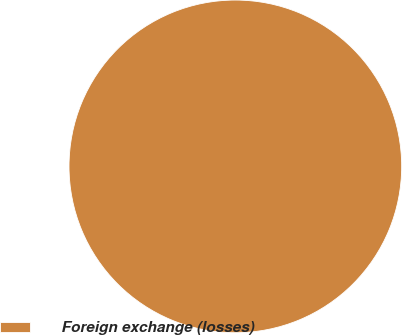Convert chart to OTSL. <chart><loc_0><loc_0><loc_500><loc_500><pie_chart><fcel>Foreign exchange (losses)<nl><fcel>100.0%<nl></chart> 